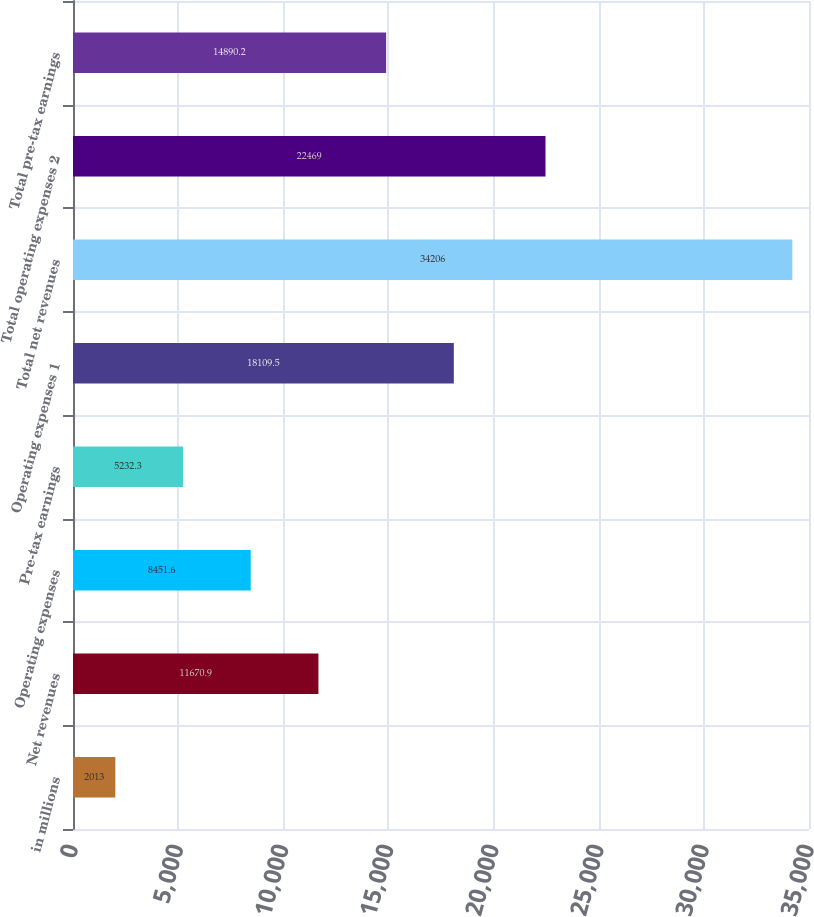Convert chart to OTSL. <chart><loc_0><loc_0><loc_500><loc_500><bar_chart><fcel>in millions<fcel>Net revenues<fcel>Operating expenses<fcel>Pre-tax earnings<fcel>Operating expenses 1<fcel>Total net revenues<fcel>Total operating expenses 2<fcel>Total pre-tax earnings<nl><fcel>2013<fcel>11670.9<fcel>8451.6<fcel>5232.3<fcel>18109.5<fcel>34206<fcel>22469<fcel>14890.2<nl></chart> 